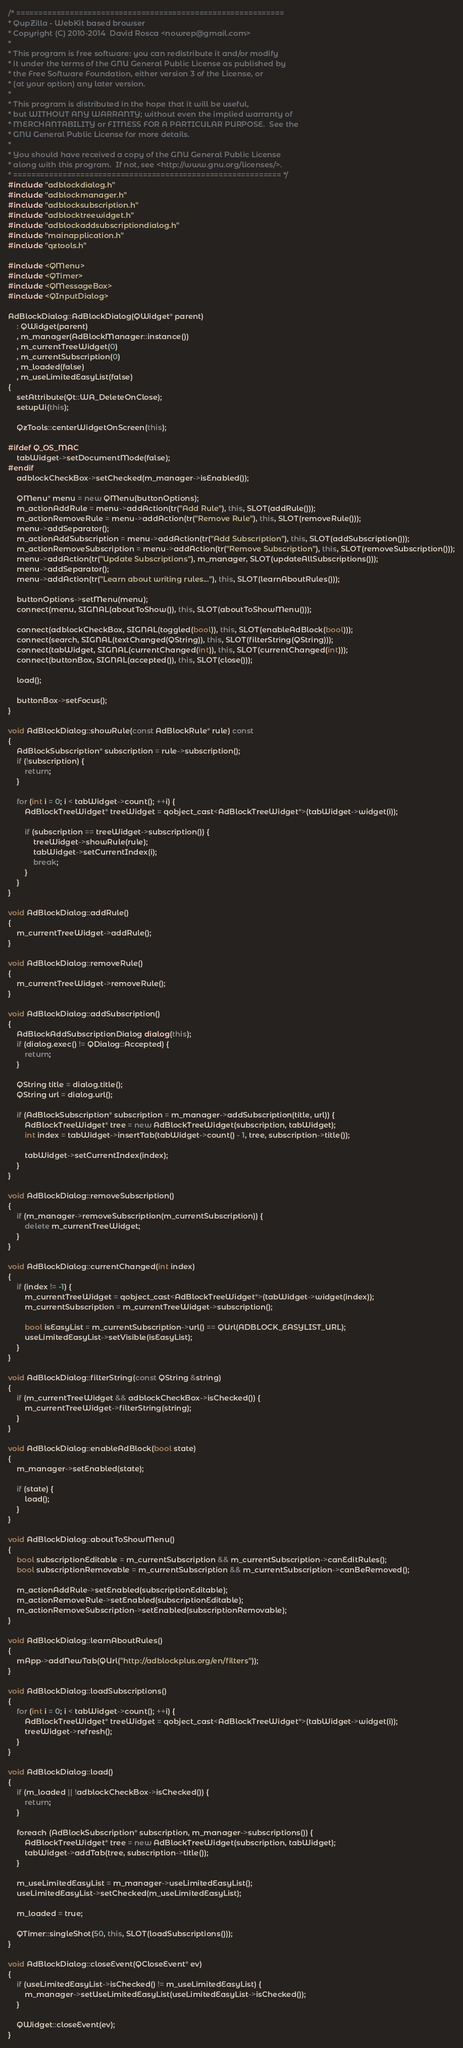Convert code to text. <code><loc_0><loc_0><loc_500><loc_500><_C++_>/* ============================================================
* QupZilla - WebKit based browser
* Copyright (C) 2010-2014  David Rosca <nowrep@gmail.com>
*
* This program is free software: you can redistribute it and/or modify
* it under the terms of the GNU General Public License as published by
* the Free Software Foundation, either version 3 of the License, or
* (at your option) any later version.
*
* This program is distributed in the hope that it will be useful,
* but WITHOUT ANY WARRANTY; without even the implied warranty of
* MERCHANTABILITY or FITNESS FOR A PARTICULAR PURPOSE.  See the
* GNU General Public License for more details.
*
* You should have received a copy of the GNU General Public License
* along with this program.  If not, see <http://www.gnu.org/licenses/>.
* ============================================================ */
#include "adblockdialog.h"
#include "adblockmanager.h"
#include "adblocksubscription.h"
#include "adblocktreewidget.h"
#include "adblockaddsubscriptiondialog.h"
#include "mainapplication.h"
#include "qztools.h"

#include <QMenu>
#include <QTimer>
#include <QMessageBox>
#include <QInputDialog>

AdBlockDialog::AdBlockDialog(QWidget* parent)
    : QWidget(parent)
    , m_manager(AdBlockManager::instance())
    , m_currentTreeWidget(0)
    , m_currentSubscription(0)
    , m_loaded(false)
    , m_useLimitedEasyList(false)
{
    setAttribute(Qt::WA_DeleteOnClose);
    setupUi(this);

    QzTools::centerWidgetOnScreen(this);

#ifdef Q_OS_MAC
    tabWidget->setDocumentMode(false);
#endif
    adblockCheckBox->setChecked(m_manager->isEnabled());

    QMenu* menu = new QMenu(buttonOptions);
    m_actionAddRule = menu->addAction(tr("Add Rule"), this, SLOT(addRule()));
    m_actionRemoveRule = menu->addAction(tr("Remove Rule"), this, SLOT(removeRule()));
    menu->addSeparator();
    m_actionAddSubscription = menu->addAction(tr("Add Subscription"), this, SLOT(addSubscription()));
    m_actionRemoveSubscription = menu->addAction(tr("Remove Subscription"), this, SLOT(removeSubscription()));
    menu->addAction(tr("Update Subscriptions"), m_manager, SLOT(updateAllSubscriptions()));
    menu->addSeparator();
    menu->addAction(tr("Learn about writing rules..."), this, SLOT(learnAboutRules()));

    buttonOptions->setMenu(menu);
    connect(menu, SIGNAL(aboutToShow()), this, SLOT(aboutToShowMenu()));

    connect(adblockCheckBox, SIGNAL(toggled(bool)), this, SLOT(enableAdBlock(bool)));
    connect(search, SIGNAL(textChanged(QString)), this, SLOT(filterString(QString)));
    connect(tabWidget, SIGNAL(currentChanged(int)), this, SLOT(currentChanged(int)));
    connect(buttonBox, SIGNAL(accepted()), this, SLOT(close()));

    load();

    buttonBox->setFocus();
}

void AdBlockDialog::showRule(const AdBlockRule* rule) const
{
    AdBlockSubscription* subscription = rule->subscription();
    if (!subscription) {
        return;
    }

    for (int i = 0; i < tabWidget->count(); ++i) {
        AdBlockTreeWidget* treeWidget = qobject_cast<AdBlockTreeWidget*>(tabWidget->widget(i));

        if (subscription == treeWidget->subscription()) {
            treeWidget->showRule(rule);
            tabWidget->setCurrentIndex(i);
            break;
        }
    }
}

void AdBlockDialog::addRule()
{
    m_currentTreeWidget->addRule();
}

void AdBlockDialog::removeRule()
{
    m_currentTreeWidget->removeRule();
}

void AdBlockDialog::addSubscription()
{
    AdBlockAddSubscriptionDialog dialog(this);
    if (dialog.exec() != QDialog::Accepted) {
        return;
    }

    QString title = dialog.title();
    QString url = dialog.url();

    if (AdBlockSubscription* subscription = m_manager->addSubscription(title, url)) {
        AdBlockTreeWidget* tree = new AdBlockTreeWidget(subscription, tabWidget);
        int index = tabWidget->insertTab(tabWidget->count() - 1, tree, subscription->title());

        tabWidget->setCurrentIndex(index);
    }
}

void AdBlockDialog::removeSubscription()
{
    if (m_manager->removeSubscription(m_currentSubscription)) {
        delete m_currentTreeWidget;
    }
}

void AdBlockDialog::currentChanged(int index)
{
    if (index != -1) {
        m_currentTreeWidget = qobject_cast<AdBlockTreeWidget*>(tabWidget->widget(index));
        m_currentSubscription = m_currentTreeWidget->subscription();

        bool isEasyList = m_currentSubscription->url() == QUrl(ADBLOCK_EASYLIST_URL);
        useLimitedEasyList->setVisible(isEasyList);
    }
}

void AdBlockDialog::filterString(const QString &string)
{
    if (m_currentTreeWidget && adblockCheckBox->isChecked()) {
        m_currentTreeWidget->filterString(string);
    }
}

void AdBlockDialog::enableAdBlock(bool state)
{
    m_manager->setEnabled(state);

    if (state) {
        load();
    }
}

void AdBlockDialog::aboutToShowMenu()
{
    bool subscriptionEditable = m_currentSubscription && m_currentSubscription->canEditRules();
    bool subscriptionRemovable = m_currentSubscription && m_currentSubscription->canBeRemoved();

    m_actionAddRule->setEnabled(subscriptionEditable);
    m_actionRemoveRule->setEnabled(subscriptionEditable);
    m_actionRemoveSubscription->setEnabled(subscriptionRemovable);
}

void AdBlockDialog::learnAboutRules()
{
    mApp->addNewTab(QUrl("http://adblockplus.org/en/filters"));
}

void AdBlockDialog::loadSubscriptions()
{
    for (int i = 0; i < tabWidget->count(); ++i) {
        AdBlockTreeWidget* treeWidget = qobject_cast<AdBlockTreeWidget*>(tabWidget->widget(i));
        treeWidget->refresh();
    }
}

void AdBlockDialog::load()
{
    if (m_loaded || !adblockCheckBox->isChecked()) {
        return;
    }

    foreach (AdBlockSubscription* subscription, m_manager->subscriptions()) {
        AdBlockTreeWidget* tree = new AdBlockTreeWidget(subscription, tabWidget);
        tabWidget->addTab(tree, subscription->title());
    }

    m_useLimitedEasyList = m_manager->useLimitedEasyList();
    useLimitedEasyList->setChecked(m_useLimitedEasyList);

    m_loaded = true;

    QTimer::singleShot(50, this, SLOT(loadSubscriptions()));
}

void AdBlockDialog::closeEvent(QCloseEvent* ev)
{
    if (useLimitedEasyList->isChecked() != m_useLimitedEasyList) {
        m_manager->setUseLimitedEasyList(useLimitedEasyList->isChecked());
    }

    QWidget::closeEvent(ev);
}
</code> 